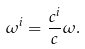<formula> <loc_0><loc_0><loc_500><loc_500>\omega ^ { i } = \frac { c ^ { i } } { c } \omega .</formula> 